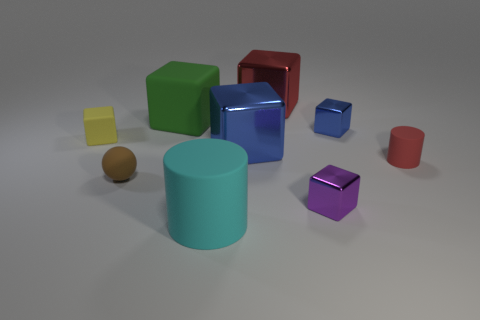Is the color of the big rubber cube the same as the tiny sphere? No, the colors are different. The big rubber cube has a green hue, while the tiny sphere appears to be brown. 